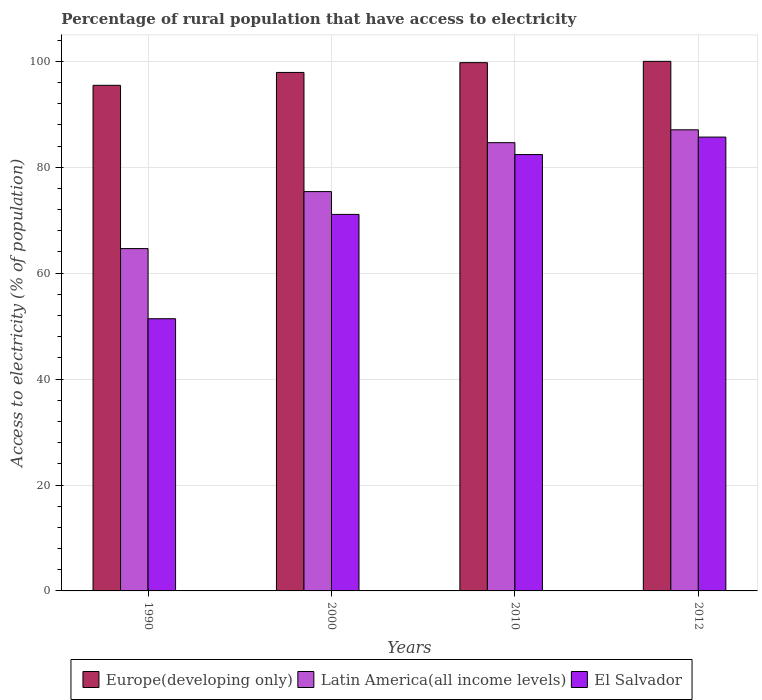Are the number of bars per tick equal to the number of legend labels?
Your response must be concise. Yes. What is the label of the 3rd group of bars from the left?
Your response must be concise. 2010. What is the percentage of rural population that have access to electricity in Europe(developing only) in 2000?
Your response must be concise. 97.91. Across all years, what is the maximum percentage of rural population that have access to electricity in El Salvador?
Your answer should be very brief. 85.7. Across all years, what is the minimum percentage of rural population that have access to electricity in El Salvador?
Provide a succinct answer. 51.4. In which year was the percentage of rural population that have access to electricity in Europe(developing only) minimum?
Give a very brief answer. 1990. What is the total percentage of rural population that have access to electricity in Europe(developing only) in the graph?
Provide a short and direct response. 393.14. What is the difference between the percentage of rural population that have access to electricity in Latin America(all income levels) in 1990 and that in 2000?
Offer a terse response. -10.76. What is the difference between the percentage of rural population that have access to electricity in El Salvador in 2010 and the percentage of rural population that have access to electricity in Latin America(all income levels) in 1990?
Offer a very short reply. 17.76. What is the average percentage of rural population that have access to electricity in Latin America(all income levels) per year?
Provide a short and direct response. 77.94. In the year 2000, what is the difference between the percentage of rural population that have access to electricity in Europe(developing only) and percentage of rural population that have access to electricity in Latin America(all income levels)?
Make the answer very short. 22.5. What is the ratio of the percentage of rural population that have access to electricity in El Salvador in 1990 to that in 2012?
Keep it short and to the point. 0.6. Is the percentage of rural population that have access to electricity in Europe(developing only) in 2000 less than that in 2012?
Give a very brief answer. Yes. What is the difference between the highest and the second highest percentage of rural population that have access to electricity in Latin America(all income levels)?
Your answer should be very brief. 2.43. What is the difference between the highest and the lowest percentage of rural population that have access to electricity in Europe(developing only)?
Your answer should be compact. 4.52. In how many years, is the percentage of rural population that have access to electricity in El Salvador greater than the average percentage of rural population that have access to electricity in El Salvador taken over all years?
Provide a succinct answer. 2. Is the sum of the percentage of rural population that have access to electricity in El Salvador in 2000 and 2010 greater than the maximum percentage of rural population that have access to electricity in Europe(developing only) across all years?
Offer a very short reply. Yes. What does the 1st bar from the left in 2010 represents?
Your answer should be very brief. Europe(developing only). What does the 2nd bar from the right in 2010 represents?
Offer a very short reply. Latin America(all income levels). Is it the case that in every year, the sum of the percentage of rural population that have access to electricity in Latin America(all income levels) and percentage of rural population that have access to electricity in El Salvador is greater than the percentage of rural population that have access to electricity in Europe(developing only)?
Your response must be concise. Yes. How many bars are there?
Provide a succinct answer. 12. What is the difference between two consecutive major ticks on the Y-axis?
Your response must be concise. 20. Does the graph contain any zero values?
Give a very brief answer. No. Where does the legend appear in the graph?
Your answer should be very brief. Bottom center. How many legend labels are there?
Your response must be concise. 3. What is the title of the graph?
Offer a very short reply. Percentage of rural population that have access to electricity. Does "Bolivia" appear as one of the legend labels in the graph?
Ensure brevity in your answer.  No. What is the label or title of the Y-axis?
Your answer should be compact. Access to electricity (% of population). What is the Access to electricity (% of population) in Europe(developing only) in 1990?
Give a very brief answer. 95.48. What is the Access to electricity (% of population) in Latin America(all income levels) in 1990?
Your answer should be compact. 64.64. What is the Access to electricity (% of population) of El Salvador in 1990?
Your answer should be very brief. 51.4. What is the Access to electricity (% of population) of Europe(developing only) in 2000?
Keep it short and to the point. 97.91. What is the Access to electricity (% of population) in Latin America(all income levels) in 2000?
Your response must be concise. 75.4. What is the Access to electricity (% of population) in El Salvador in 2000?
Your answer should be compact. 71.1. What is the Access to electricity (% of population) of Europe(developing only) in 2010?
Keep it short and to the point. 99.76. What is the Access to electricity (% of population) of Latin America(all income levels) in 2010?
Provide a short and direct response. 84.64. What is the Access to electricity (% of population) of El Salvador in 2010?
Offer a very short reply. 82.4. What is the Access to electricity (% of population) in Latin America(all income levels) in 2012?
Provide a short and direct response. 87.07. What is the Access to electricity (% of population) of El Salvador in 2012?
Offer a terse response. 85.7. Across all years, what is the maximum Access to electricity (% of population) of Latin America(all income levels)?
Your answer should be compact. 87.07. Across all years, what is the maximum Access to electricity (% of population) of El Salvador?
Ensure brevity in your answer.  85.7. Across all years, what is the minimum Access to electricity (% of population) in Europe(developing only)?
Keep it short and to the point. 95.48. Across all years, what is the minimum Access to electricity (% of population) in Latin America(all income levels)?
Give a very brief answer. 64.64. Across all years, what is the minimum Access to electricity (% of population) of El Salvador?
Provide a short and direct response. 51.4. What is the total Access to electricity (% of population) in Europe(developing only) in the graph?
Keep it short and to the point. 393.14. What is the total Access to electricity (% of population) in Latin America(all income levels) in the graph?
Give a very brief answer. 311.76. What is the total Access to electricity (% of population) in El Salvador in the graph?
Keep it short and to the point. 290.6. What is the difference between the Access to electricity (% of population) in Europe(developing only) in 1990 and that in 2000?
Offer a very short reply. -2.43. What is the difference between the Access to electricity (% of population) in Latin America(all income levels) in 1990 and that in 2000?
Your answer should be very brief. -10.76. What is the difference between the Access to electricity (% of population) of El Salvador in 1990 and that in 2000?
Your response must be concise. -19.7. What is the difference between the Access to electricity (% of population) of Europe(developing only) in 1990 and that in 2010?
Provide a short and direct response. -4.28. What is the difference between the Access to electricity (% of population) in Latin America(all income levels) in 1990 and that in 2010?
Provide a succinct answer. -20. What is the difference between the Access to electricity (% of population) of El Salvador in 1990 and that in 2010?
Ensure brevity in your answer.  -31. What is the difference between the Access to electricity (% of population) of Europe(developing only) in 1990 and that in 2012?
Offer a terse response. -4.52. What is the difference between the Access to electricity (% of population) of Latin America(all income levels) in 1990 and that in 2012?
Give a very brief answer. -22.43. What is the difference between the Access to electricity (% of population) of El Salvador in 1990 and that in 2012?
Make the answer very short. -34.3. What is the difference between the Access to electricity (% of population) of Europe(developing only) in 2000 and that in 2010?
Make the answer very short. -1.85. What is the difference between the Access to electricity (% of population) in Latin America(all income levels) in 2000 and that in 2010?
Your answer should be very brief. -9.24. What is the difference between the Access to electricity (% of population) in Europe(developing only) in 2000 and that in 2012?
Ensure brevity in your answer.  -2.09. What is the difference between the Access to electricity (% of population) of Latin America(all income levels) in 2000 and that in 2012?
Offer a very short reply. -11.67. What is the difference between the Access to electricity (% of population) in El Salvador in 2000 and that in 2012?
Make the answer very short. -14.6. What is the difference between the Access to electricity (% of population) in Europe(developing only) in 2010 and that in 2012?
Your answer should be compact. -0.24. What is the difference between the Access to electricity (% of population) in Latin America(all income levels) in 2010 and that in 2012?
Ensure brevity in your answer.  -2.43. What is the difference between the Access to electricity (% of population) in El Salvador in 2010 and that in 2012?
Offer a very short reply. -3.3. What is the difference between the Access to electricity (% of population) of Europe(developing only) in 1990 and the Access to electricity (% of population) of Latin America(all income levels) in 2000?
Make the answer very short. 20.07. What is the difference between the Access to electricity (% of population) in Europe(developing only) in 1990 and the Access to electricity (% of population) in El Salvador in 2000?
Keep it short and to the point. 24.38. What is the difference between the Access to electricity (% of population) of Latin America(all income levels) in 1990 and the Access to electricity (% of population) of El Salvador in 2000?
Provide a short and direct response. -6.46. What is the difference between the Access to electricity (% of population) in Europe(developing only) in 1990 and the Access to electricity (% of population) in Latin America(all income levels) in 2010?
Provide a succinct answer. 10.83. What is the difference between the Access to electricity (% of population) of Europe(developing only) in 1990 and the Access to electricity (% of population) of El Salvador in 2010?
Ensure brevity in your answer.  13.08. What is the difference between the Access to electricity (% of population) of Latin America(all income levels) in 1990 and the Access to electricity (% of population) of El Salvador in 2010?
Keep it short and to the point. -17.76. What is the difference between the Access to electricity (% of population) in Europe(developing only) in 1990 and the Access to electricity (% of population) in Latin America(all income levels) in 2012?
Provide a succinct answer. 8.4. What is the difference between the Access to electricity (% of population) of Europe(developing only) in 1990 and the Access to electricity (% of population) of El Salvador in 2012?
Provide a short and direct response. 9.78. What is the difference between the Access to electricity (% of population) in Latin America(all income levels) in 1990 and the Access to electricity (% of population) in El Salvador in 2012?
Make the answer very short. -21.06. What is the difference between the Access to electricity (% of population) in Europe(developing only) in 2000 and the Access to electricity (% of population) in Latin America(all income levels) in 2010?
Provide a succinct answer. 13.27. What is the difference between the Access to electricity (% of population) in Europe(developing only) in 2000 and the Access to electricity (% of population) in El Salvador in 2010?
Give a very brief answer. 15.51. What is the difference between the Access to electricity (% of population) in Latin America(all income levels) in 2000 and the Access to electricity (% of population) in El Salvador in 2010?
Offer a terse response. -7. What is the difference between the Access to electricity (% of population) of Europe(developing only) in 2000 and the Access to electricity (% of population) of Latin America(all income levels) in 2012?
Give a very brief answer. 10.84. What is the difference between the Access to electricity (% of population) of Europe(developing only) in 2000 and the Access to electricity (% of population) of El Salvador in 2012?
Your answer should be compact. 12.21. What is the difference between the Access to electricity (% of population) of Latin America(all income levels) in 2000 and the Access to electricity (% of population) of El Salvador in 2012?
Your answer should be compact. -10.3. What is the difference between the Access to electricity (% of population) of Europe(developing only) in 2010 and the Access to electricity (% of population) of Latin America(all income levels) in 2012?
Offer a very short reply. 12.68. What is the difference between the Access to electricity (% of population) in Europe(developing only) in 2010 and the Access to electricity (% of population) in El Salvador in 2012?
Make the answer very short. 14.06. What is the difference between the Access to electricity (% of population) of Latin America(all income levels) in 2010 and the Access to electricity (% of population) of El Salvador in 2012?
Make the answer very short. -1.06. What is the average Access to electricity (% of population) in Europe(developing only) per year?
Provide a short and direct response. 98.28. What is the average Access to electricity (% of population) in Latin America(all income levels) per year?
Give a very brief answer. 77.94. What is the average Access to electricity (% of population) in El Salvador per year?
Keep it short and to the point. 72.65. In the year 1990, what is the difference between the Access to electricity (% of population) in Europe(developing only) and Access to electricity (% of population) in Latin America(all income levels)?
Keep it short and to the point. 30.83. In the year 1990, what is the difference between the Access to electricity (% of population) of Europe(developing only) and Access to electricity (% of population) of El Salvador?
Offer a very short reply. 44.08. In the year 1990, what is the difference between the Access to electricity (% of population) of Latin America(all income levels) and Access to electricity (% of population) of El Salvador?
Provide a succinct answer. 13.24. In the year 2000, what is the difference between the Access to electricity (% of population) in Europe(developing only) and Access to electricity (% of population) in Latin America(all income levels)?
Make the answer very short. 22.5. In the year 2000, what is the difference between the Access to electricity (% of population) of Europe(developing only) and Access to electricity (% of population) of El Salvador?
Make the answer very short. 26.81. In the year 2000, what is the difference between the Access to electricity (% of population) of Latin America(all income levels) and Access to electricity (% of population) of El Salvador?
Your answer should be compact. 4.3. In the year 2010, what is the difference between the Access to electricity (% of population) in Europe(developing only) and Access to electricity (% of population) in Latin America(all income levels)?
Provide a short and direct response. 15.11. In the year 2010, what is the difference between the Access to electricity (% of population) in Europe(developing only) and Access to electricity (% of population) in El Salvador?
Keep it short and to the point. 17.36. In the year 2010, what is the difference between the Access to electricity (% of population) in Latin America(all income levels) and Access to electricity (% of population) in El Salvador?
Your response must be concise. 2.24. In the year 2012, what is the difference between the Access to electricity (% of population) in Europe(developing only) and Access to electricity (% of population) in Latin America(all income levels)?
Offer a terse response. 12.93. In the year 2012, what is the difference between the Access to electricity (% of population) of Latin America(all income levels) and Access to electricity (% of population) of El Salvador?
Offer a very short reply. 1.37. What is the ratio of the Access to electricity (% of population) of Europe(developing only) in 1990 to that in 2000?
Your answer should be compact. 0.98. What is the ratio of the Access to electricity (% of population) in Latin America(all income levels) in 1990 to that in 2000?
Keep it short and to the point. 0.86. What is the ratio of the Access to electricity (% of population) of El Salvador in 1990 to that in 2000?
Offer a very short reply. 0.72. What is the ratio of the Access to electricity (% of population) in Europe(developing only) in 1990 to that in 2010?
Offer a very short reply. 0.96. What is the ratio of the Access to electricity (% of population) in Latin America(all income levels) in 1990 to that in 2010?
Keep it short and to the point. 0.76. What is the ratio of the Access to electricity (% of population) of El Salvador in 1990 to that in 2010?
Ensure brevity in your answer.  0.62. What is the ratio of the Access to electricity (% of population) of Europe(developing only) in 1990 to that in 2012?
Keep it short and to the point. 0.95. What is the ratio of the Access to electricity (% of population) of Latin America(all income levels) in 1990 to that in 2012?
Your answer should be very brief. 0.74. What is the ratio of the Access to electricity (% of population) of El Salvador in 1990 to that in 2012?
Offer a terse response. 0.6. What is the ratio of the Access to electricity (% of population) of Europe(developing only) in 2000 to that in 2010?
Keep it short and to the point. 0.98. What is the ratio of the Access to electricity (% of population) of Latin America(all income levels) in 2000 to that in 2010?
Provide a short and direct response. 0.89. What is the ratio of the Access to electricity (% of population) of El Salvador in 2000 to that in 2010?
Your response must be concise. 0.86. What is the ratio of the Access to electricity (% of population) in Europe(developing only) in 2000 to that in 2012?
Keep it short and to the point. 0.98. What is the ratio of the Access to electricity (% of population) of Latin America(all income levels) in 2000 to that in 2012?
Make the answer very short. 0.87. What is the ratio of the Access to electricity (% of population) in El Salvador in 2000 to that in 2012?
Keep it short and to the point. 0.83. What is the ratio of the Access to electricity (% of population) of Latin America(all income levels) in 2010 to that in 2012?
Your response must be concise. 0.97. What is the ratio of the Access to electricity (% of population) of El Salvador in 2010 to that in 2012?
Provide a short and direct response. 0.96. What is the difference between the highest and the second highest Access to electricity (% of population) of Europe(developing only)?
Your response must be concise. 0.24. What is the difference between the highest and the second highest Access to electricity (% of population) in Latin America(all income levels)?
Your response must be concise. 2.43. What is the difference between the highest and the lowest Access to electricity (% of population) in Europe(developing only)?
Your answer should be very brief. 4.52. What is the difference between the highest and the lowest Access to electricity (% of population) of Latin America(all income levels)?
Offer a terse response. 22.43. What is the difference between the highest and the lowest Access to electricity (% of population) of El Salvador?
Your response must be concise. 34.3. 